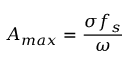Convert formula to latex. <formula><loc_0><loc_0><loc_500><loc_500>A _ { \max } = { \frac { \sigma f _ { s } } { \omega } }</formula> 